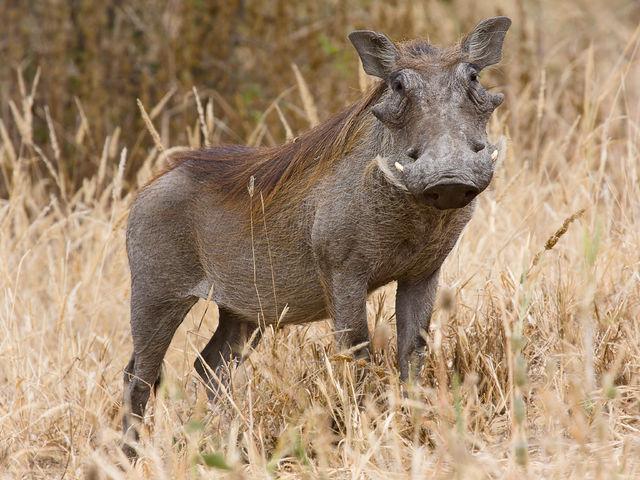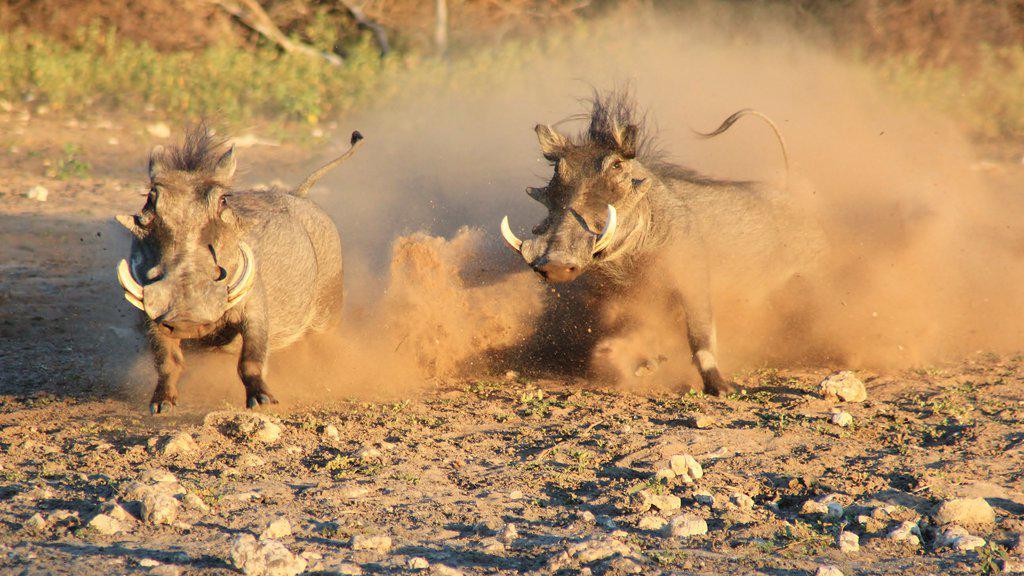The first image is the image on the left, the second image is the image on the right. For the images shown, is this caption "The right image contains twice as many warthogs as the left image, and all warthogs are turned forward instead of in profile or backward." true? Answer yes or no. Yes. The first image is the image on the left, the second image is the image on the right. Assess this claim about the two images: "There is exactly two warthogs in the left image.". Correct or not? Answer yes or no. No. 